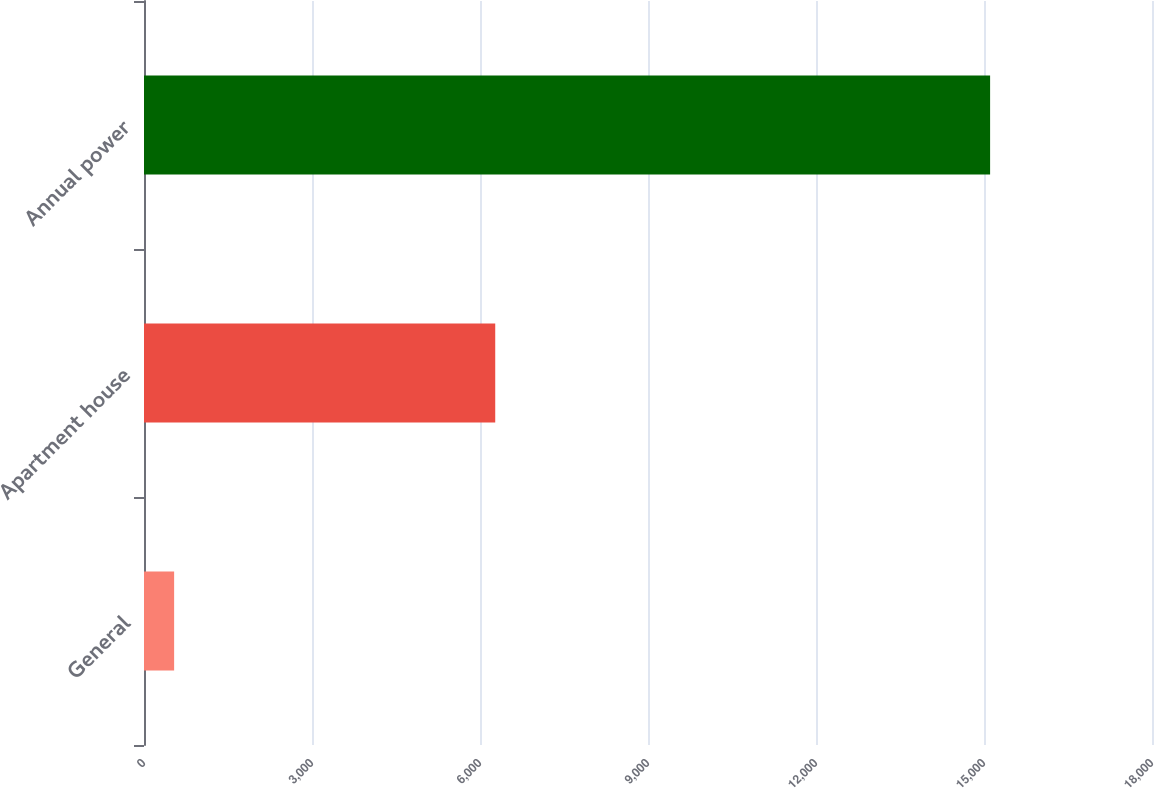Convert chart. <chart><loc_0><loc_0><loc_500><loc_500><bar_chart><fcel>General<fcel>Apartment house<fcel>Annual power<nl><fcel>538<fcel>6272<fcel>15109<nl></chart> 